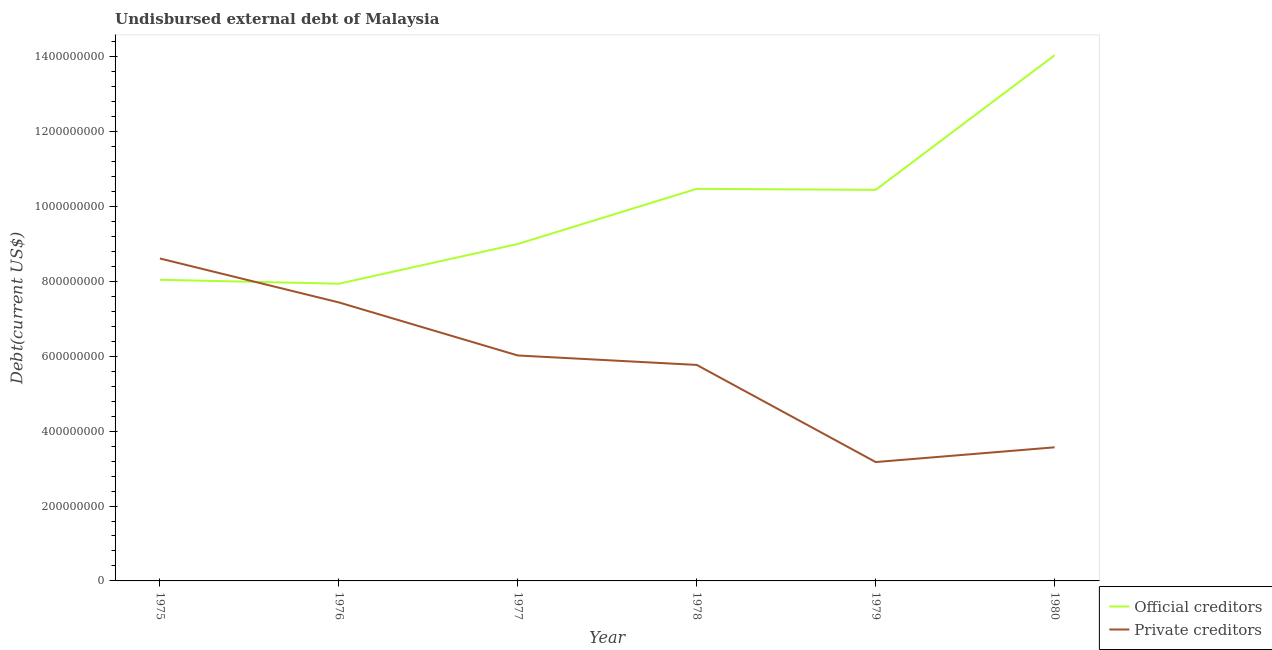Does the line corresponding to undisbursed external debt of official creditors intersect with the line corresponding to undisbursed external debt of private creditors?
Provide a succinct answer. Yes. Is the number of lines equal to the number of legend labels?
Your answer should be compact. Yes. What is the undisbursed external debt of private creditors in 1976?
Provide a short and direct response. 7.44e+08. Across all years, what is the maximum undisbursed external debt of official creditors?
Offer a very short reply. 1.40e+09. Across all years, what is the minimum undisbursed external debt of official creditors?
Give a very brief answer. 7.94e+08. In which year was the undisbursed external debt of private creditors maximum?
Keep it short and to the point. 1975. In which year was the undisbursed external debt of private creditors minimum?
Give a very brief answer. 1979. What is the total undisbursed external debt of official creditors in the graph?
Give a very brief answer. 5.99e+09. What is the difference between the undisbursed external debt of private creditors in 1975 and that in 1977?
Provide a short and direct response. 2.59e+08. What is the difference between the undisbursed external debt of private creditors in 1978 and the undisbursed external debt of official creditors in 1977?
Ensure brevity in your answer.  -3.23e+08. What is the average undisbursed external debt of private creditors per year?
Your response must be concise. 5.76e+08. In the year 1977, what is the difference between the undisbursed external debt of private creditors and undisbursed external debt of official creditors?
Provide a short and direct response. -2.98e+08. What is the ratio of the undisbursed external debt of private creditors in 1978 to that in 1980?
Your response must be concise. 1.62. Is the difference between the undisbursed external debt of private creditors in 1976 and 1979 greater than the difference between the undisbursed external debt of official creditors in 1976 and 1979?
Give a very brief answer. Yes. What is the difference between the highest and the second highest undisbursed external debt of official creditors?
Give a very brief answer. 3.57e+08. What is the difference between the highest and the lowest undisbursed external debt of private creditors?
Your answer should be very brief. 5.44e+08. In how many years, is the undisbursed external debt of private creditors greater than the average undisbursed external debt of private creditors taken over all years?
Your answer should be compact. 4. Is the sum of the undisbursed external debt of private creditors in 1979 and 1980 greater than the maximum undisbursed external debt of official creditors across all years?
Give a very brief answer. No. Is the undisbursed external debt of official creditors strictly greater than the undisbursed external debt of private creditors over the years?
Keep it short and to the point. No. How many years are there in the graph?
Keep it short and to the point. 6. Does the graph contain grids?
Provide a short and direct response. No. Where does the legend appear in the graph?
Your answer should be compact. Bottom right. How many legend labels are there?
Your answer should be compact. 2. How are the legend labels stacked?
Give a very brief answer. Vertical. What is the title of the graph?
Keep it short and to the point. Undisbursed external debt of Malaysia. Does "Travel services" appear as one of the legend labels in the graph?
Make the answer very short. No. What is the label or title of the Y-axis?
Provide a short and direct response. Debt(current US$). What is the Debt(current US$) in Official creditors in 1975?
Make the answer very short. 8.04e+08. What is the Debt(current US$) in Private creditors in 1975?
Your answer should be compact. 8.61e+08. What is the Debt(current US$) in Official creditors in 1976?
Offer a terse response. 7.94e+08. What is the Debt(current US$) in Private creditors in 1976?
Your response must be concise. 7.44e+08. What is the Debt(current US$) in Official creditors in 1977?
Your answer should be compact. 9.00e+08. What is the Debt(current US$) in Private creditors in 1977?
Provide a succinct answer. 6.02e+08. What is the Debt(current US$) of Official creditors in 1978?
Your answer should be compact. 1.05e+09. What is the Debt(current US$) in Private creditors in 1978?
Offer a very short reply. 5.77e+08. What is the Debt(current US$) of Official creditors in 1979?
Give a very brief answer. 1.04e+09. What is the Debt(current US$) of Private creditors in 1979?
Ensure brevity in your answer.  3.17e+08. What is the Debt(current US$) in Official creditors in 1980?
Your answer should be very brief. 1.40e+09. What is the Debt(current US$) of Private creditors in 1980?
Ensure brevity in your answer.  3.57e+08. Across all years, what is the maximum Debt(current US$) of Official creditors?
Make the answer very short. 1.40e+09. Across all years, what is the maximum Debt(current US$) of Private creditors?
Provide a short and direct response. 8.61e+08. Across all years, what is the minimum Debt(current US$) of Official creditors?
Provide a succinct answer. 7.94e+08. Across all years, what is the minimum Debt(current US$) in Private creditors?
Provide a short and direct response. 3.17e+08. What is the total Debt(current US$) of Official creditors in the graph?
Your answer should be compact. 5.99e+09. What is the total Debt(current US$) of Private creditors in the graph?
Give a very brief answer. 3.46e+09. What is the difference between the Debt(current US$) of Official creditors in 1975 and that in 1976?
Offer a terse response. 1.06e+07. What is the difference between the Debt(current US$) of Private creditors in 1975 and that in 1976?
Keep it short and to the point. 1.17e+08. What is the difference between the Debt(current US$) of Official creditors in 1975 and that in 1977?
Provide a short and direct response. -9.55e+07. What is the difference between the Debt(current US$) of Private creditors in 1975 and that in 1977?
Give a very brief answer. 2.59e+08. What is the difference between the Debt(current US$) of Official creditors in 1975 and that in 1978?
Provide a succinct answer. -2.43e+08. What is the difference between the Debt(current US$) of Private creditors in 1975 and that in 1978?
Make the answer very short. 2.84e+08. What is the difference between the Debt(current US$) in Official creditors in 1975 and that in 1979?
Provide a succinct answer. -2.40e+08. What is the difference between the Debt(current US$) of Private creditors in 1975 and that in 1979?
Your answer should be very brief. 5.44e+08. What is the difference between the Debt(current US$) in Official creditors in 1975 and that in 1980?
Give a very brief answer. -6.00e+08. What is the difference between the Debt(current US$) in Private creditors in 1975 and that in 1980?
Provide a succinct answer. 5.04e+08. What is the difference between the Debt(current US$) of Official creditors in 1976 and that in 1977?
Offer a terse response. -1.06e+08. What is the difference between the Debt(current US$) of Private creditors in 1976 and that in 1977?
Your answer should be compact. 1.42e+08. What is the difference between the Debt(current US$) in Official creditors in 1976 and that in 1978?
Ensure brevity in your answer.  -2.53e+08. What is the difference between the Debt(current US$) of Private creditors in 1976 and that in 1978?
Provide a short and direct response. 1.67e+08. What is the difference between the Debt(current US$) of Official creditors in 1976 and that in 1979?
Make the answer very short. -2.51e+08. What is the difference between the Debt(current US$) in Private creditors in 1976 and that in 1979?
Provide a short and direct response. 4.26e+08. What is the difference between the Debt(current US$) of Official creditors in 1976 and that in 1980?
Your response must be concise. -6.10e+08. What is the difference between the Debt(current US$) in Private creditors in 1976 and that in 1980?
Offer a terse response. 3.87e+08. What is the difference between the Debt(current US$) in Official creditors in 1977 and that in 1978?
Your answer should be very brief. -1.47e+08. What is the difference between the Debt(current US$) in Private creditors in 1977 and that in 1978?
Give a very brief answer. 2.52e+07. What is the difference between the Debt(current US$) in Official creditors in 1977 and that in 1979?
Your response must be concise. -1.45e+08. What is the difference between the Debt(current US$) of Private creditors in 1977 and that in 1979?
Offer a terse response. 2.85e+08. What is the difference between the Debt(current US$) in Official creditors in 1977 and that in 1980?
Ensure brevity in your answer.  -5.04e+08. What is the difference between the Debt(current US$) in Private creditors in 1977 and that in 1980?
Provide a succinct answer. 2.45e+08. What is the difference between the Debt(current US$) in Official creditors in 1978 and that in 1979?
Give a very brief answer. 2.75e+06. What is the difference between the Debt(current US$) in Private creditors in 1978 and that in 1979?
Make the answer very short. 2.59e+08. What is the difference between the Debt(current US$) in Official creditors in 1978 and that in 1980?
Give a very brief answer. -3.57e+08. What is the difference between the Debt(current US$) of Private creditors in 1978 and that in 1980?
Ensure brevity in your answer.  2.20e+08. What is the difference between the Debt(current US$) in Official creditors in 1979 and that in 1980?
Provide a succinct answer. -3.60e+08. What is the difference between the Debt(current US$) of Private creditors in 1979 and that in 1980?
Provide a succinct answer. -3.94e+07. What is the difference between the Debt(current US$) in Official creditors in 1975 and the Debt(current US$) in Private creditors in 1976?
Make the answer very short. 6.05e+07. What is the difference between the Debt(current US$) of Official creditors in 1975 and the Debt(current US$) of Private creditors in 1977?
Your answer should be very brief. 2.02e+08. What is the difference between the Debt(current US$) of Official creditors in 1975 and the Debt(current US$) of Private creditors in 1978?
Keep it short and to the point. 2.27e+08. What is the difference between the Debt(current US$) of Official creditors in 1975 and the Debt(current US$) of Private creditors in 1979?
Provide a short and direct response. 4.87e+08. What is the difference between the Debt(current US$) in Official creditors in 1975 and the Debt(current US$) in Private creditors in 1980?
Your response must be concise. 4.47e+08. What is the difference between the Debt(current US$) of Official creditors in 1976 and the Debt(current US$) of Private creditors in 1977?
Offer a very short reply. 1.92e+08. What is the difference between the Debt(current US$) in Official creditors in 1976 and the Debt(current US$) in Private creditors in 1978?
Make the answer very short. 2.17e+08. What is the difference between the Debt(current US$) in Official creditors in 1976 and the Debt(current US$) in Private creditors in 1979?
Make the answer very short. 4.76e+08. What is the difference between the Debt(current US$) in Official creditors in 1976 and the Debt(current US$) in Private creditors in 1980?
Offer a terse response. 4.37e+08. What is the difference between the Debt(current US$) in Official creditors in 1977 and the Debt(current US$) in Private creditors in 1978?
Your answer should be very brief. 3.23e+08. What is the difference between the Debt(current US$) in Official creditors in 1977 and the Debt(current US$) in Private creditors in 1979?
Provide a short and direct response. 5.82e+08. What is the difference between the Debt(current US$) in Official creditors in 1977 and the Debt(current US$) in Private creditors in 1980?
Offer a very short reply. 5.43e+08. What is the difference between the Debt(current US$) in Official creditors in 1978 and the Debt(current US$) in Private creditors in 1979?
Offer a very short reply. 7.30e+08. What is the difference between the Debt(current US$) in Official creditors in 1978 and the Debt(current US$) in Private creditors in 1980?
Make the answer very short. 6.90e+08. What is the difference between the Debt(current US$) of Official creditors in 1979 and the Debt(current US$) of Private creditors in 1980?
Offer a terse response. 6.88e+08. What is the average Debt(current US$) of Official creditors per year?
Your response must be concise. 9.99e+08. What is the average Debt(current US$) of Private creditors per year?
Ensure brevity in your answer.  5.76e+08. In the year 1975, what is the difference between the Debt(current US$) in Official creditors and Debt(current US$) in Private creditors?
Offer a terse response. -5.68e+07. In the year 1976, what is the difference between the Debt(current US$) in Official creditors and Debt(current US$) in Private creditors?
Give a very brief answer. 4.99e+07. In the year 1977, what is the difference between the Debt(current US$) in Official creditors and Debt(current US$) in Private creditors?
Keep it short and to the point. 2.98e+08. In the year 1978, what is the difference between the Debt(current US$) of Official creditors and Debt(current US$) of Private creditors?
Your response must be concise. 4.70e+08. In the year 1979, what is the difference between the Debt(current US$) of Official creditors and Debt(current US$) of Private creditors?
Give a very brief answer. 7.27e+08. In the year 1980, what is the difference between the Debt(current US$) in Official creditors and Debt(current US$) in Private creditors?
Offer a very short reply. 1.05e+09. What is the ratio of the Debt(current US$) of Official creditors in 1975 to that in 1976?
Ensure brevity in your answer.  1.01. What is the ratio of the Debt(current US$) of Private creditors in 1975 to that in 1976?
Provide a short and direct response. 1.16. What is the ratio of the Debt(current US$) of Official creditors in 1975 to that in 1977?
Make the answer very short. 0.89. What is the ratio of the Debt(current US$) of Private creditors in 1975 to that in 1977?
Offer a very short reply. 1.43. What is the ratio of the Debt(current US$) of Official creditors in 1975 to that in 1978?
Give a very brief answer. 0.77. What is the ratio of the Debt(current US$) of Private creditors in 1975 to that in 1978?
Your response must be concise. 1.49. What is the ratio of the Debt(current US$) of Official creditors in 1975 to that in 1979?
Make the answer very short. 0.77. What is the ratio of the Debt(current US$) of Private creditors in 1975 to that in 1979?
Ensure brevity in your answer.  2.71. What is the ratio of the Debt(current US$) in Official creditors in 1975 to that in 1980?
Your answer should be compact. 0.57. What is the ratio of the Debt(current US$) of Private creditors in 1975 to that in 1980?
Your response must be concise. 2.41. What is the ratio of the Debt(current US$) of Official creditors in 1976 to that in 1977?
Make the answer very short. 0.88. What is the ratio of the Debt(current US$) in Private creditors in 1976 to that in 1977?
Ensure brevity in your answer.  1.24. What is the ratio of the Debt(current US$) in Official creditors in 1976 to that in 1978?
Give a very brief answer. 0.76. What is the ratio of the Debt(current US$) in Private creditors in 1976 to that in 1978?
Offer a terse response. 1.29. What is the ratio of the Debt(current US$) in Official creditors in 1976 to that in 1979?
Your answer should be compact. 0.76. What is the ratio of the Debt(current US$) in Private creditors in 1976 to that in 1979?
Make the answer very short. 2.34. What is the ratio of the Debt(current US$) in Official creditors in 1976 to that in 1980?
Make the answer very short. 0.57. What is the ratio of the Debt(current US$) of Private creditors in 1976 to that in 1980?
Your answer should be compact. 2.08. What is the ratio of the Debt(current US$) of Official creditors in 1977 to that in 1978?
Provide a short and direct response. 0.86. What is the ratio of the Debt(current US$) in Private creditors in 1977 to that in 1978?
Offer a terse response. 1.04. What is the ratio of the Debt(current US$) of Official creditors in 1977 to that in 1979?
Your answer should be compact. 0.86. What is the ratio of the Debt(current US$) of Private creditors in 1977 to that in 1979?
Offer a very short reply. 1.9. What is the ratio of the Debt(current US$) in Official creditors in 1977 to that in 1980?
Make the answer very short. 0.64. What is the ratio of the Debt(current US$) of Private creditors in 1977 to that in 1980?
Offer a terse response. 1.69. What is the ratio of the Debt(current US$) in Official creditors in 1978 to that in 1979?
Keep it short and to the point. 1. What is the ratio of the Debt(current US$) in Private creditors in 1978 to that in 1979?
Ensure brevity in your answer.  1.82. What is the ratio of the Debt(current US$) of Official creditors in 1978 to that in 1980?
Give a very brief answer. 0.75. What is the ratio of the Debt(current US$) of Private creditors in 1978 to that in 1980?
Provide a short and direct response. 1.62. What is the ratio of the Debt(current US$) of Official creditors in 1979 to that in 1980?
Offer a very short reply. 0.74. What is the ratio of the Debt(current US$) of Private creditors in 1979 to that in 1980?
Give a very brief answer. 0.89. What is the difference between the highest and the second highest Debt(current US$) of Official creditors?
Keep it short and to the point. 3.57e+08. What is the difference between the highest and the second highest Debt(current US$) of Private creditors?
Make the answer very short. 1.17e+08. What is the difference between the highest and the lowest Debt(current US$) of Official creditors?
Keep it short and to the point. 6.10e+08. What is the difference between the highest and the lowest Debt(current US$) of Private creditors?
Make the answer very short. 5.44e+08. 